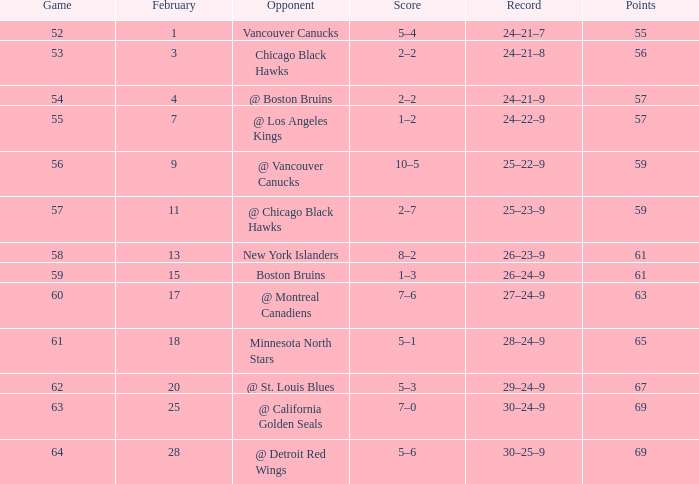Which competitor has a game exceeding 61, february less than 28, and a score under 69? @ St. Louis Blues. 